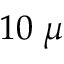Convert formula to latex. <formula><loc_0><loc_0><loc_500><loc_500>1 0 \, \mu</formula> 